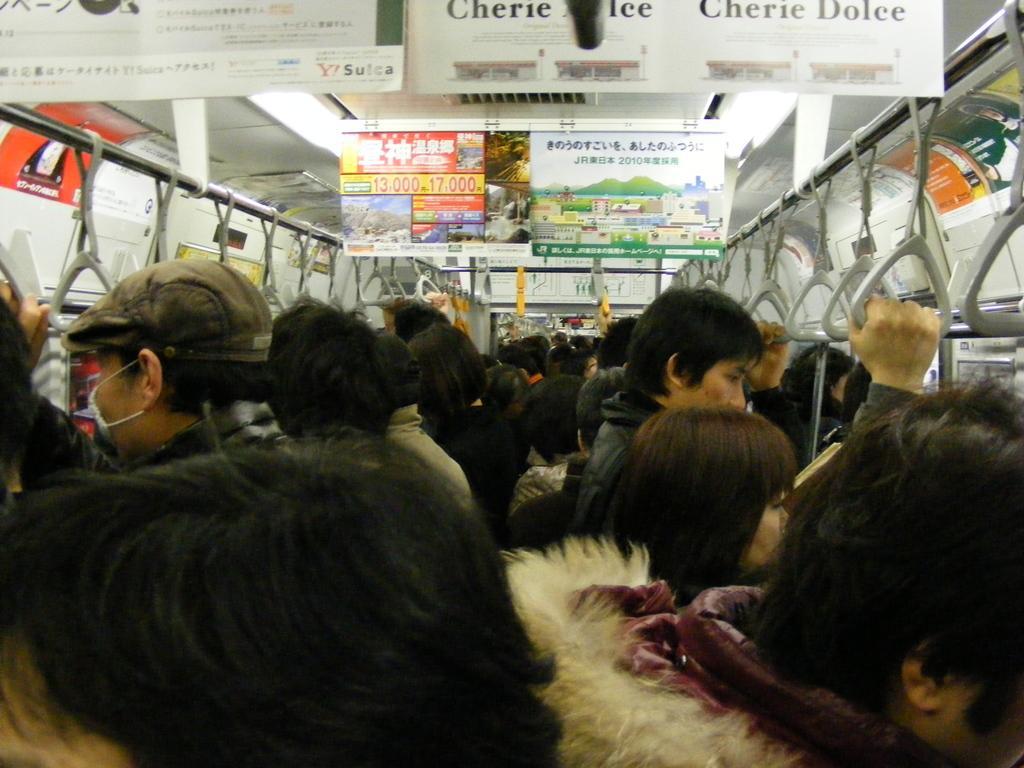Can you describe this image briefly? In the picture we can see some people are standing in the train tightly and holding a ceiling rod with belts and to the ceiling we can see some boards hanged for it. 